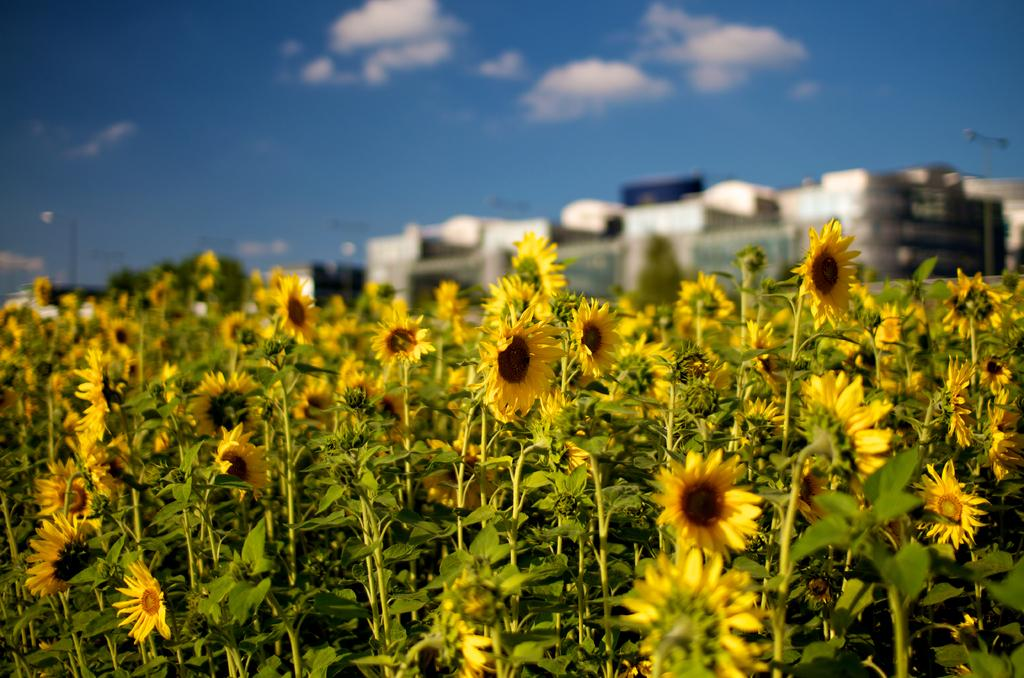What type of plants can be seen in the image? There are plants with flowers in the image. What can be seen in the background of the image? There are buildings and the sky visible in the background of the image. Where is the secretary working in the image? There is no secretary present in the image. What type of field can be seen in the image? There is no field present in the image. 